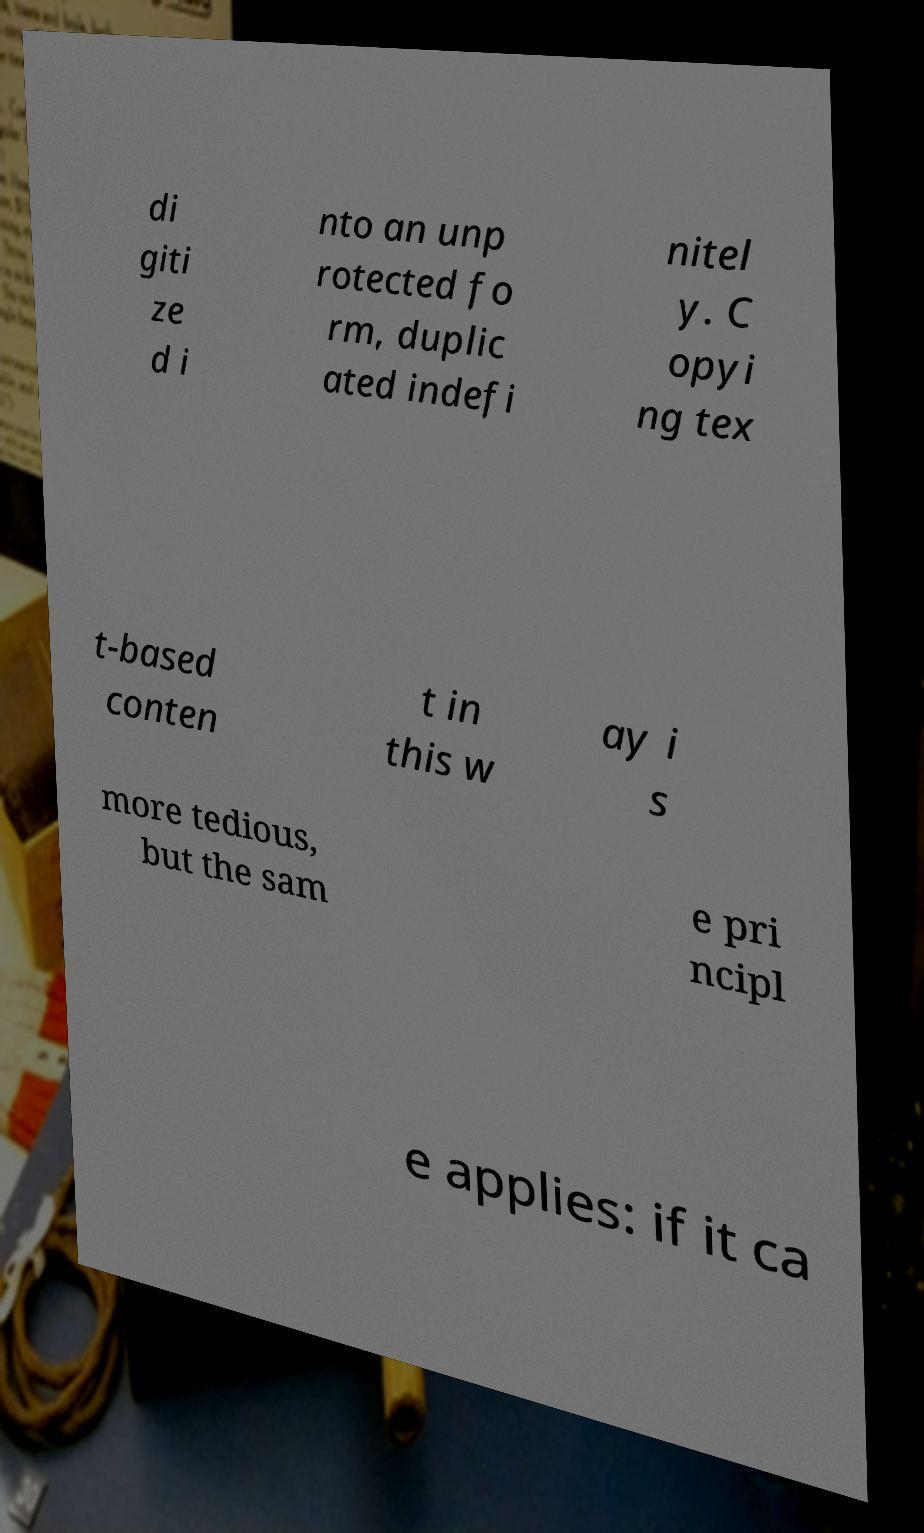Could you assist in decoding the text presented in this image and type it out clearly? di giti ze d i nto an unp rotected fo rm, duplic ated indefi nitel y. C opyi ng tex t-based conten t in this w ay i s more tedious, but the sam e pri ncipl e applies: if it ca 